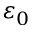Convert formula to latex. <formula><loc_0><loc_0><loc_500><loc_500>\varepsilon _ { 0 }</formula> 